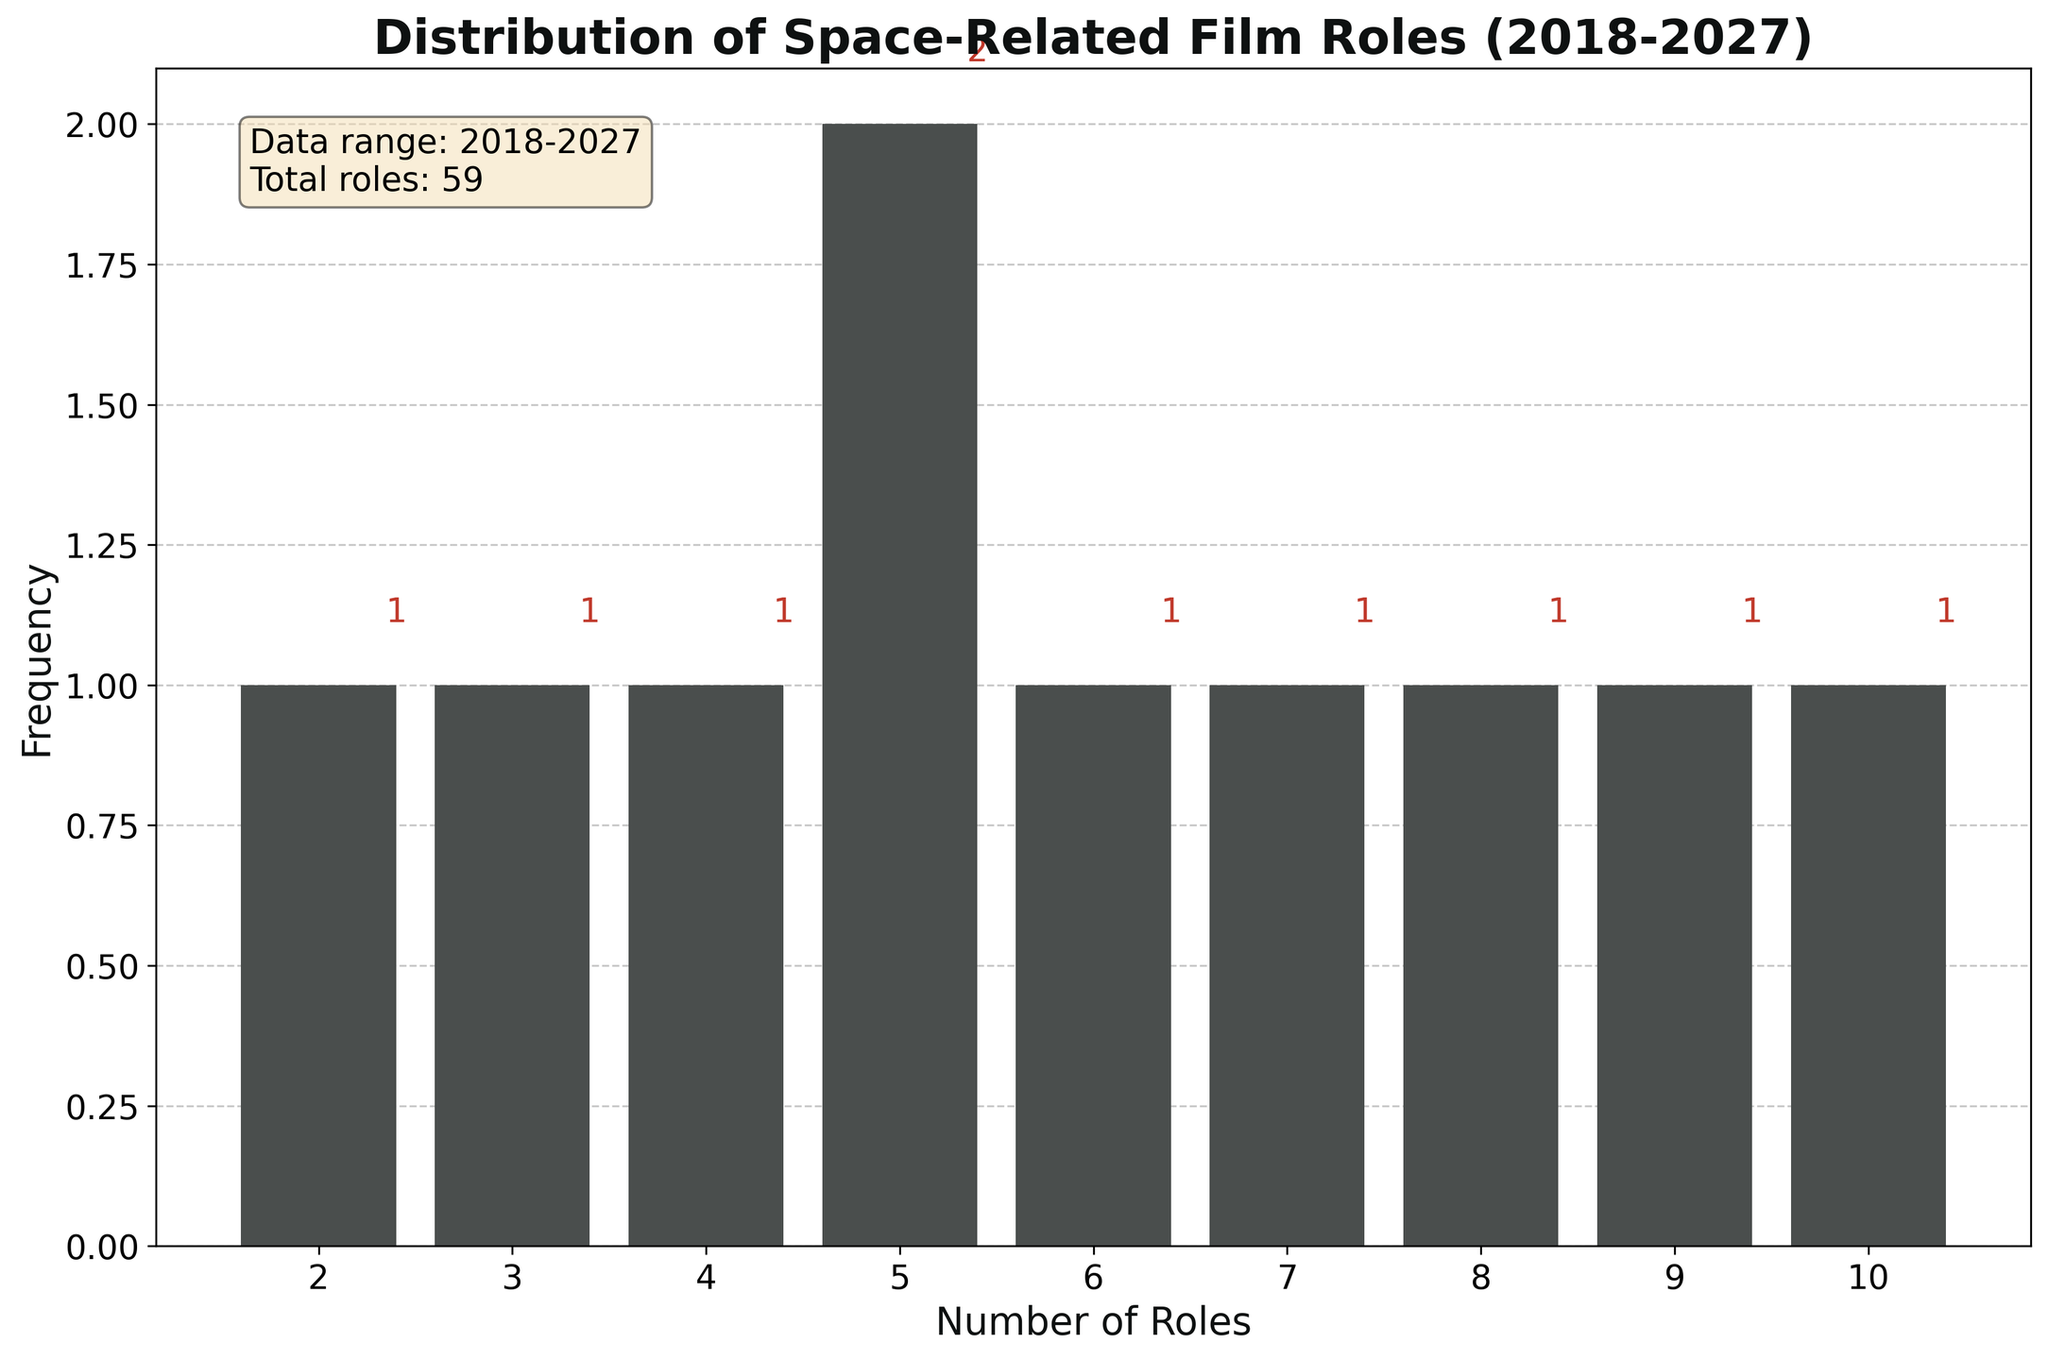What is the title of the histogram? The title is located at the top of the histogram and is usually bold and prominent. It reads "Distribution of Space-Related Film Roles (2018-2027)."
Answer: Distribution of Space-Related Film Roles (2018-2027) What is the maximum number of space-related film roles offered in any single year? Find the highest value on the x-axis, where the number of roles is indicated. This value corresponds to the maximum number of film roles offered, which is 10.
Answer: 10 How many years had exactly 5 space-related film roles offered? Locate the bin corresponding to "5" on the x-axis and check the frequency (height of the bar). Then, refer to the value printed on top of the bar, which shows "2."
Answer: 2 How many total roles were offered from 2018 to 2027? The total number of roles is mentioned in the text box within the histogram. It states "Total roles: 49."
Answer: 49 What is the frequency of the least occurring number of roles offered? Identify the shortest bar in the histogram and check the value printed above it. The shortest bar corresponds to "2" roles with a frequency of "1."
Answer: 1 Which year had the highest frequency of space-related film roles? Look for the year corresponding to the tallest bar in the histogram, which indicates the highest frequency. The tallest bar corresponds to "10" roles.
Answer: 2027 What is the range of the number of roles offered per year? The range can be found by subtracting the smallest number of roles (2) from the largest number of roles (10).
Answer: 8 How many years had more than 6 film roles offered? Count the bars on the histogram where the number of roles (x-axis) is greater than 6. The bars corresponding to 7, 8, 9, and 10 each have a frequency of 1, making a total of 4 years.
Answer: 4 What is the average number of space-related film roles offered per year during 2018-2027? Sum the total roles offered (49) and divide by the span of years (10 years). The average number of roles is 49/10 = 4.9.
Answer: 4.9 